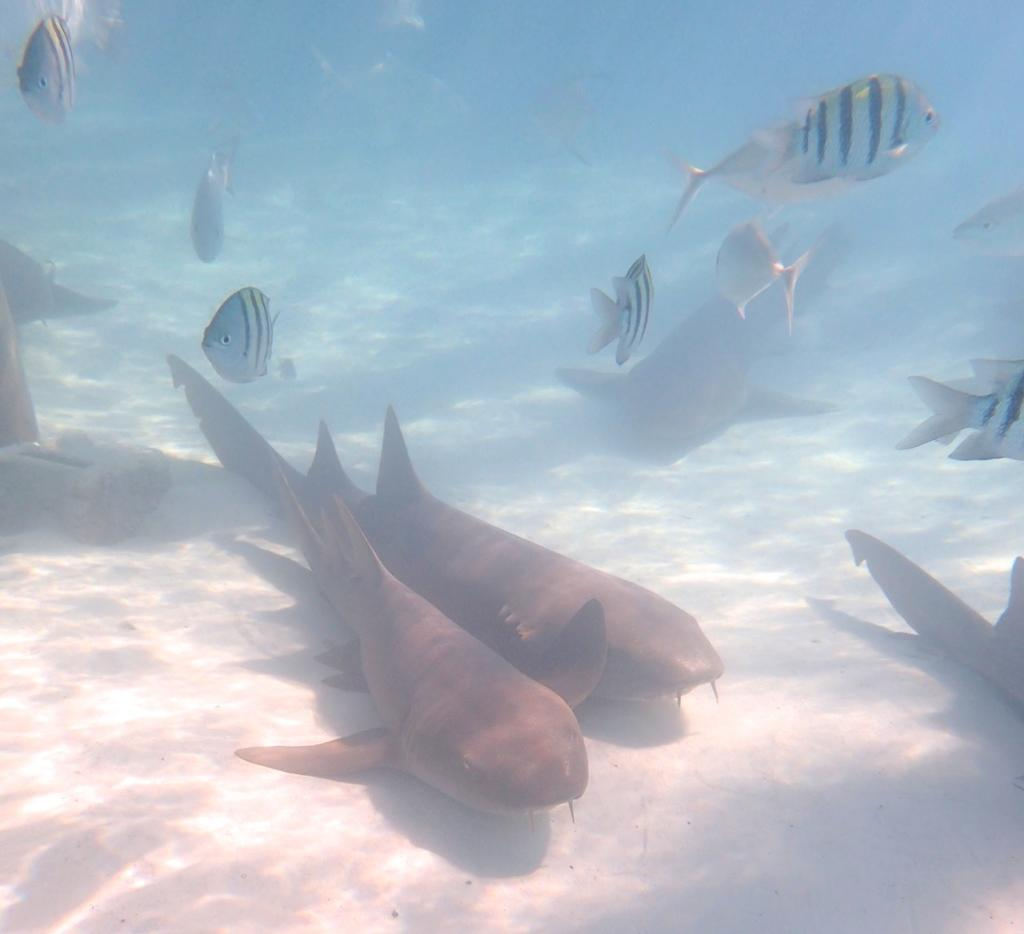What type of animals can be seen in the image? Fish can be seen in the water. In what environment are the fish located? The fish are located in the water. What type of calendar is hanging on the wall near the fish in the image? There is no calendar present in the image; it only features fish in the water. 